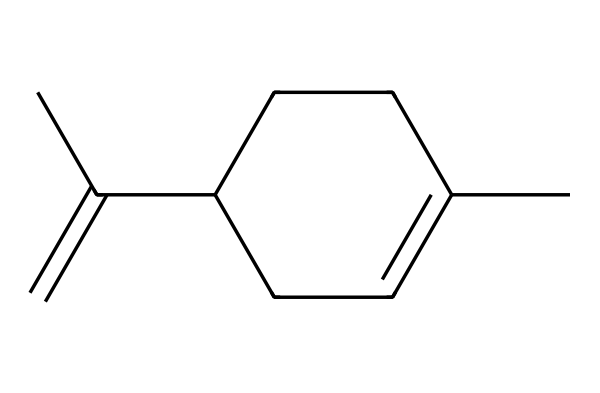What is the molecular formula of limonene? To determine the molecular formula, count the number of each type of atom in the chemical structure represented by the SMILES. In this case, there are 10 carbon (C) atoms and 16 hydrogen (H) atoms, which gives us the formula C10H16.
Answer: C10H16 How many double bonds are present in limonene? Inspect the chemical structure for double bonds. In the SMILES representation, there are two double bonds indicated by the '=' signs. Therefore, limonene contains 2 double bonds.
Answer: 2 What type of isomerism is exhibited by limonene? Limonene exists in two stereo-specific forms, known as enantiomers, which are mirror images of each other (D-limonene and L-limonene). This indicates the presence of chiral centers in its structure.
Answer: enantiomerism What is the ring structure present in limonene? The chemical structure contains a cycloalkene part, specifically a cyclohexene ring. This is identified by the cyclic arrangement of carbon atoms in the structure.
Answer: cyclohexene How does the structure of limonene affect its smell? The structure contains a specific arrangement of carbon and double bonds that contribute to its characteristic citrus scent. This structural feature affects how it interacts with olfactory receptors.
Answer: citrus scent What possibly contributes to limonene's solubility in organic solvents? The presence of non-polar carbon chains and functional groups in the structure allows limonene to dissolve well in non-polar organic solvents but limits its solubility in polar solvents like water.
Answer: non-polar carbon chains How is limonene classified in terms of its natural occurrence? Limonene is classified as a natural terpene, specifically a monoterpene, as it is derived from essential oils of citrus fruits and consists of two isoprene units.
Answer: monoterpene 